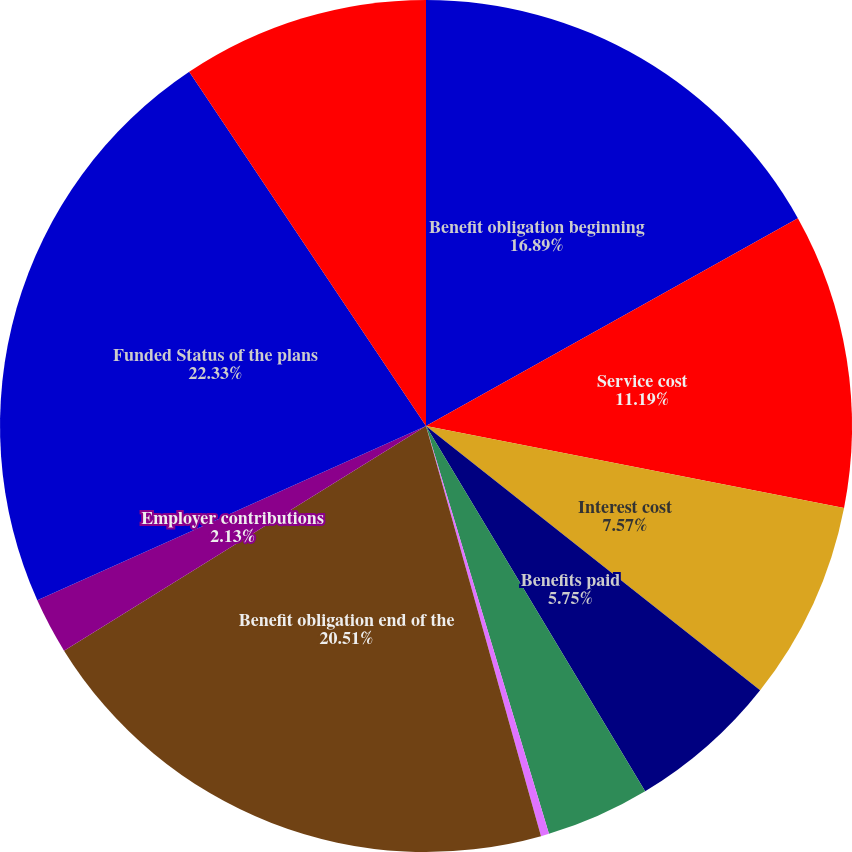Convert chart. <chart><loc_0><loc_0><loc_500><loc_500><pie_chart><fcel>Benefit obligation beginning<fcel>Service cost<fcel>Interest cost<fcel>Benefits paid<fcel>Actuarial gain (loss)<fcel>Assumption changes<fcel>Benefit obligation end of the<fcel>Employer contributions<fcel>Funded Status of the plans<fcel>Pension and retirement<nl><fcel>16.89%<fcel>11.19%<fcel>7.57%<fcel>5.75%<fcel>3.94%<fcel>0.31%<fcel>20.51%<fcel>2.13%<fcel>22.33%<fcel>9.38%<nl></chart> 